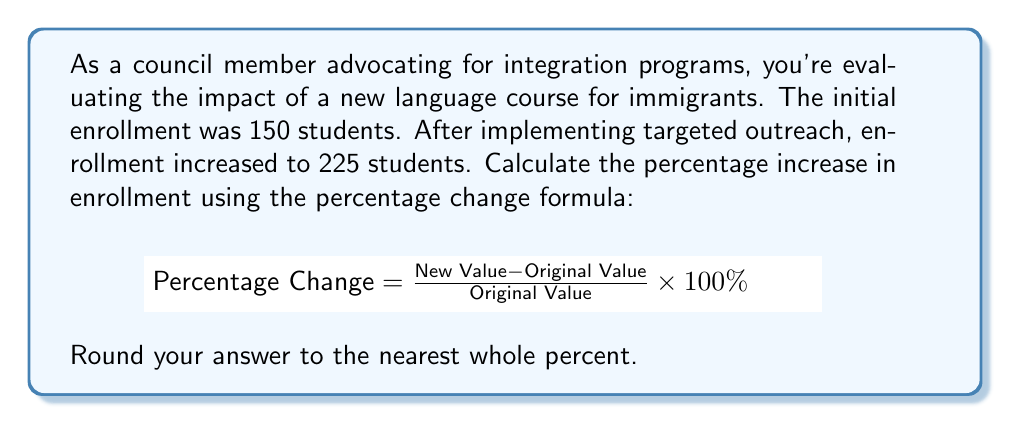Can you answer this question? Let's approach this step-by-step:

1) We're given:
   Original Value (initial enrollment) = 150 students
   New Value (enrollment after outreach) = 225 students

2) Let's plug these values into the percentage change formula:

   $$\text{Percentage Change} = \frac{225 - 150}{150} \times 100\%$$

3) Simplify the numerator:

   $$\text{Percentage Change} = \frac{75}{150} \times 100\%$$

4) Divide 75 by 150:

   $$\text{Percentage Change} = 0.5 \times 100\%$$

5) Multiply by 100% to convert to a percentage:

   $$\text{Percentage Change} = 50\%$$

6) The question asks to round to the nearest whole percent, but 50% is already a whole number, so no further rounding is necessary.

Therefore, the enrollment increased by 50%.
Answer: 50% 